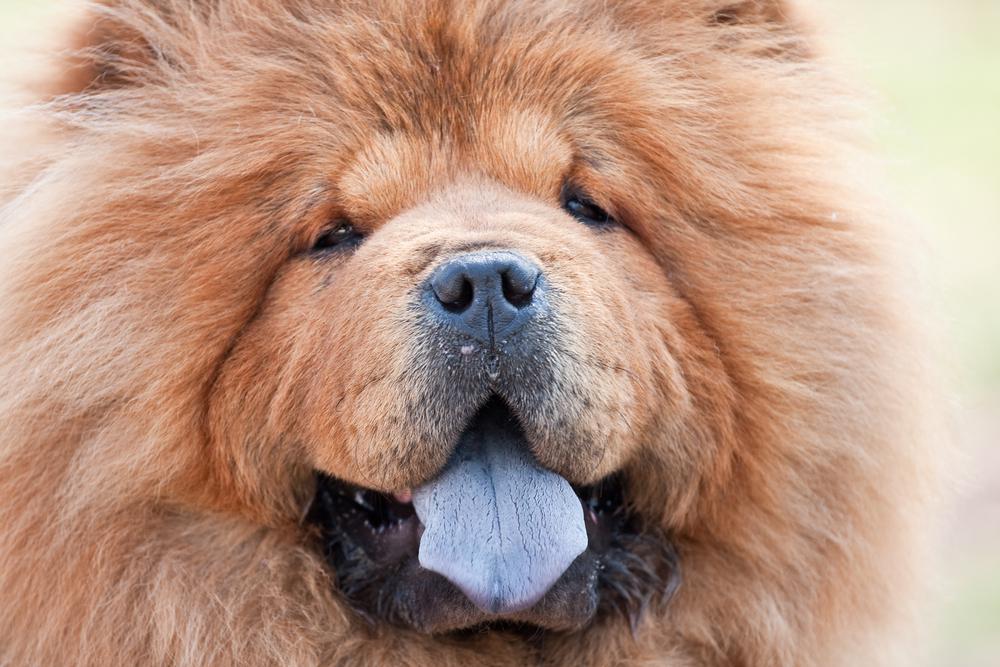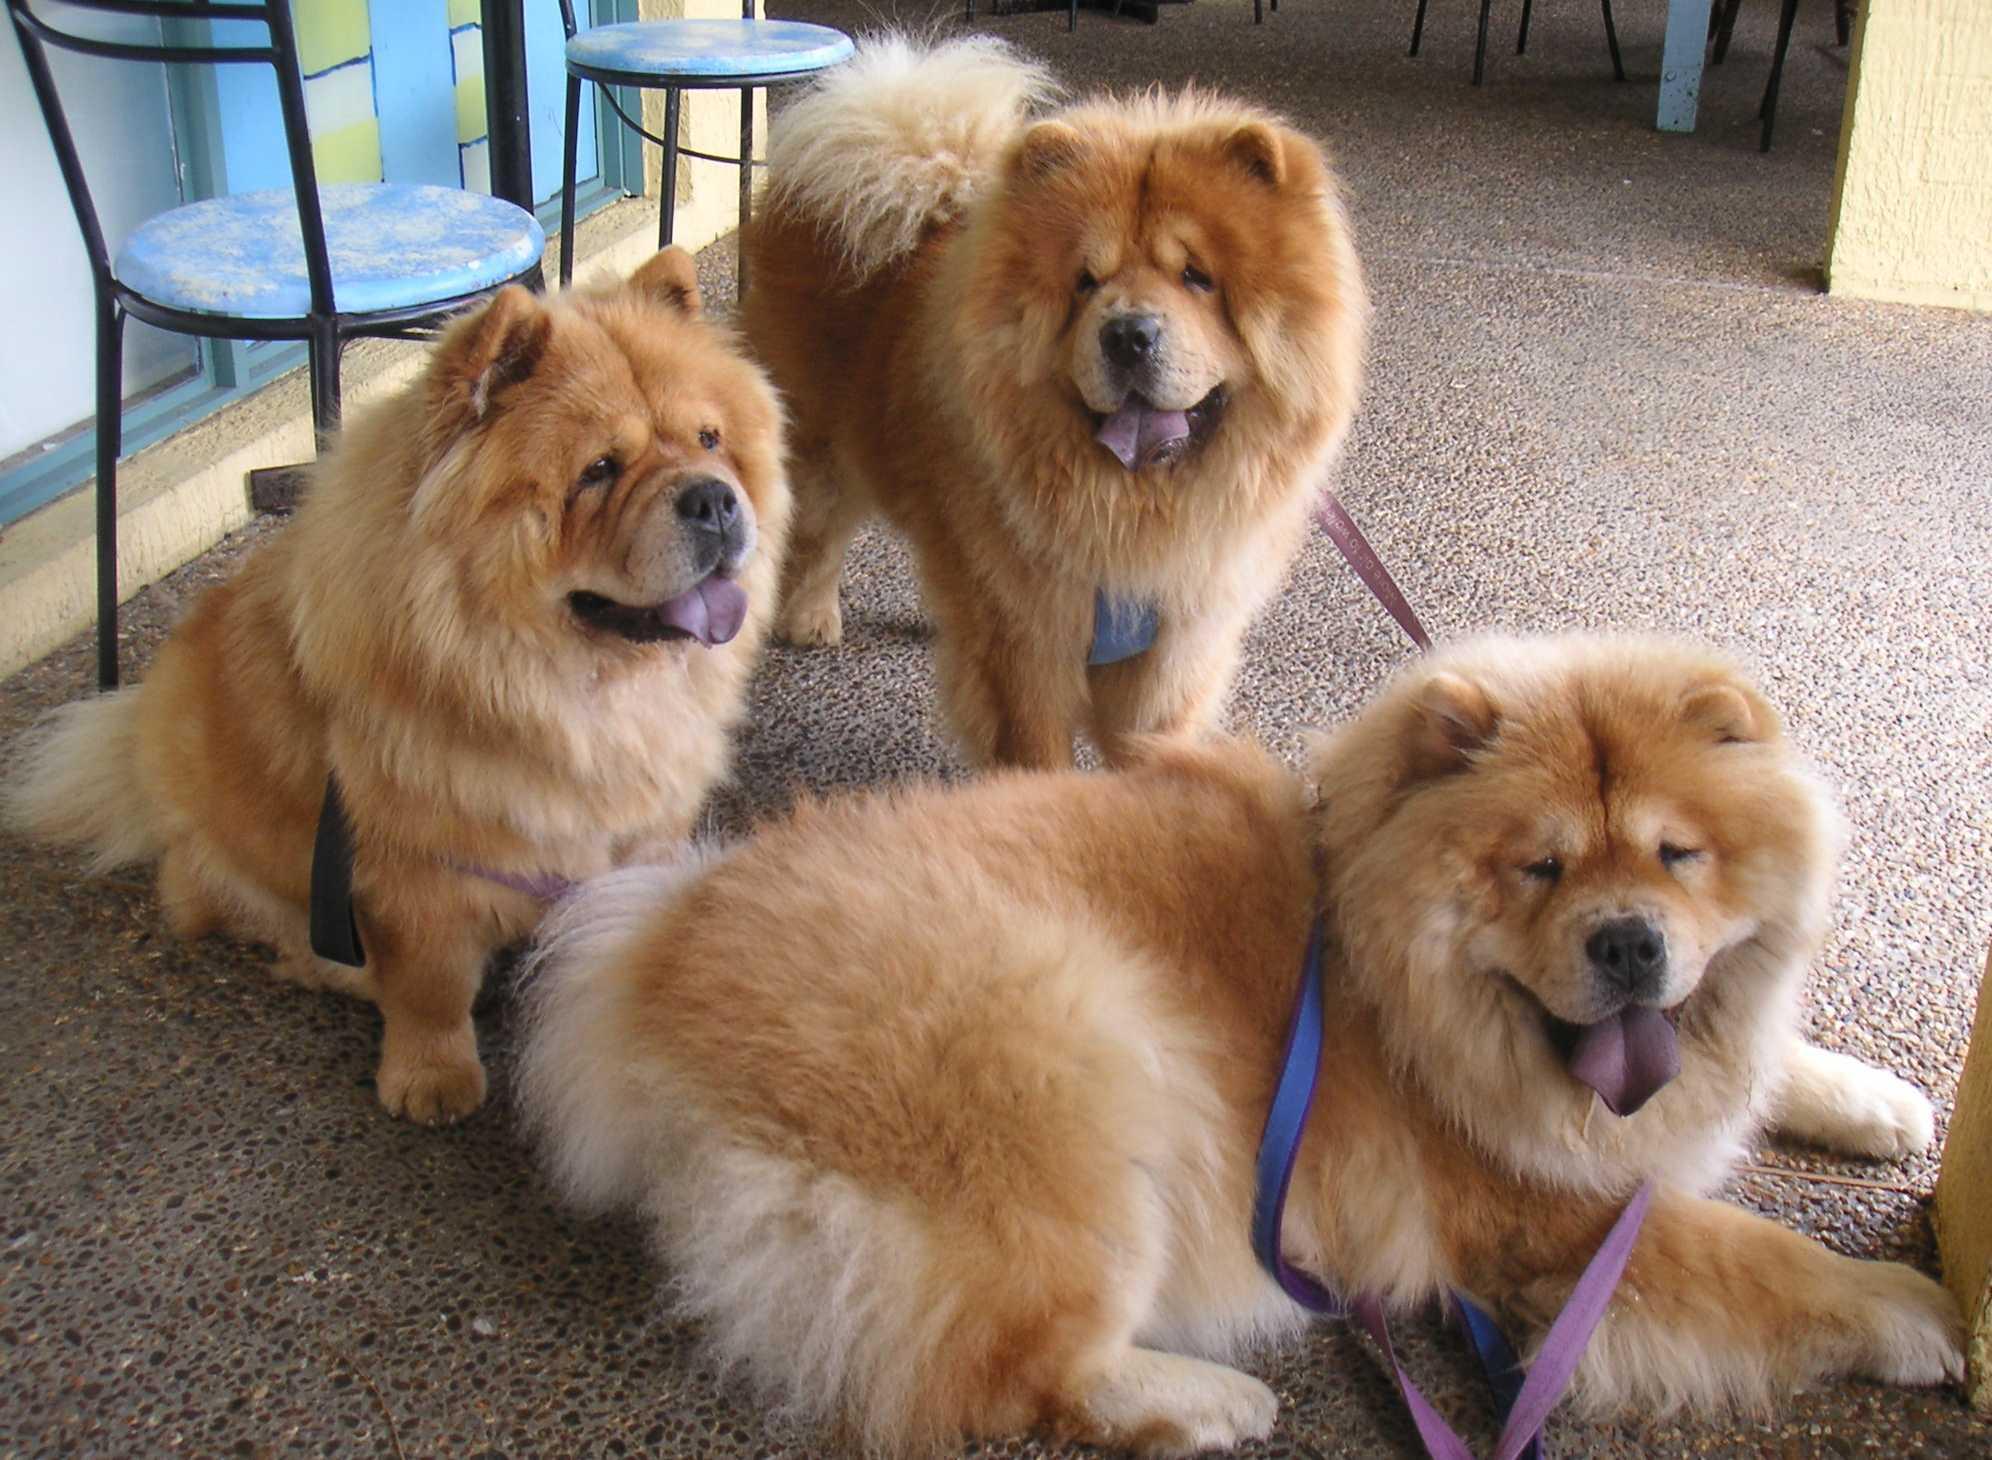The first image is the image on the left, the second image is the image on the right. For the images displayed, is the sentence "There are at most two dogs." factually correct? Answer yes or no. No. The first image is the image on the left, the second image is the image on the right. Examine the images to the left and right. Is the description "The right image contains at least two chow dogs." accurate? Answer yes or no. Yes. 